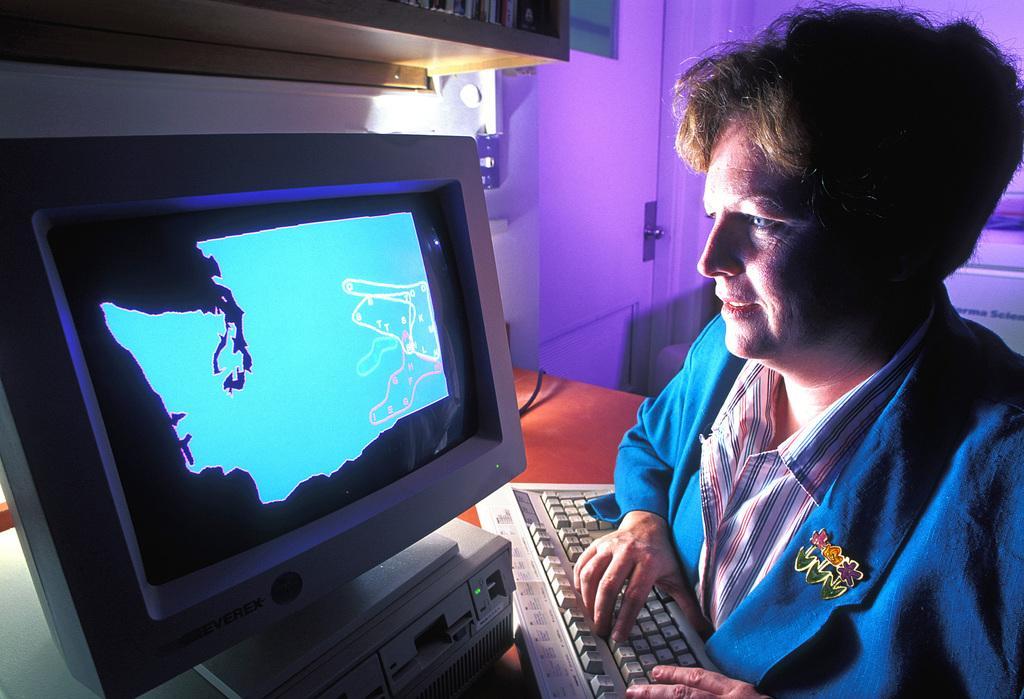Please provide a concise description of this image. In this image we can see a person. In front of the person, we can see the monitor and keyboard. In the background, we can see a door and the wall. It seems like a rack at the top of the image. 